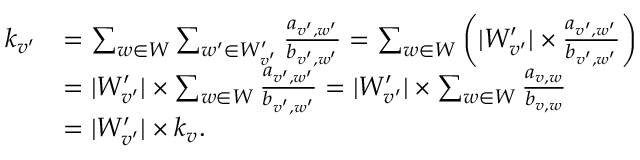<formula> <loc_0><loc_0><loc_500><loc_500>\begin{array} { r l } { k _ { v ^ { \prime } } } & { = \sum _ { w \in W } \sum _ { w ^ { \prime } \in W _ { v ^ { \prime } } ^ { \prime } } \frac { a _ { v ^ { \prime } , w ^ { \prime } } } { b _ { v ^ { \prime } , w ^ { \prime } } } = \sum _ { w \in W } \left ( | W _ { v ^ { \prime } } ^ { \prime } | \times \frac { a _ { v ^ { \prime } , w ^ { \prime } } } { b _ { v ^ { \prime } , w ^ { \prime } } } \right ) } \\ & { = | W _ { v ^ { \prime } } ^ { \prime } | \times \sum _ { w \in W } \frac { a _ { v ^ { \prime } , w ^ { \prime } } } { b _ { v ^ { \prime } , w ^ { \prime } } } = | W _ { v ^ { \prime } } ^ { \prime } | \times \sum _ { w \in W } \frac { a _ { v , w } } { b _ { v , w } } } \\ & { = | W _ { v ^ { \prime } } ^ { \prime } | \times k _ { v } . } \end{array}</formula> 